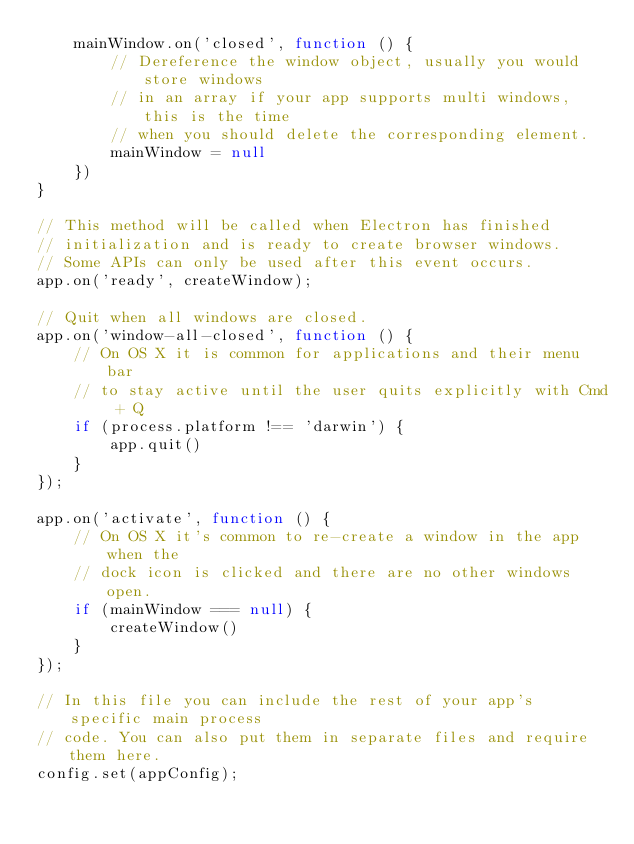Convert code to text. <code><loc_0><loc_0><loc_500><loc_500><_JavaScript_>    mainWindow.on('closed', function () {
        // Dereference the window object, usually you would store windows
        // in an array if your app supports multi windows, this is the time
        // when you should delete the corresponding element.
        mainWindow = null
    })
}

// This method will be called when Electron has finished
// initialization and is ready to create browser windows.
// Some APIs can only be used after this event occurs.
app.on('ready', createWindow);

// Quit when all windows are closed.
app.on('window-all-closed', function () {
    // On OS X it is common for applications and their menu bar
    // to stay active until the user quits explicitly with Cmd + Q
    if (process.platform !== 'darwin') {
        app.quit()
    }
});

app.on('activate', function () {
    // On OS X it's common to re-create a window in the app when the
    // dock icon is clicked and there are no other windows open.
    if (mainWindow === null) {
        createWindow()
    }
});

// In this file you can include the rest of your app's specific main process
// code. You can also put them in separate files and require them here.
config.set(appConfig);
</code> 